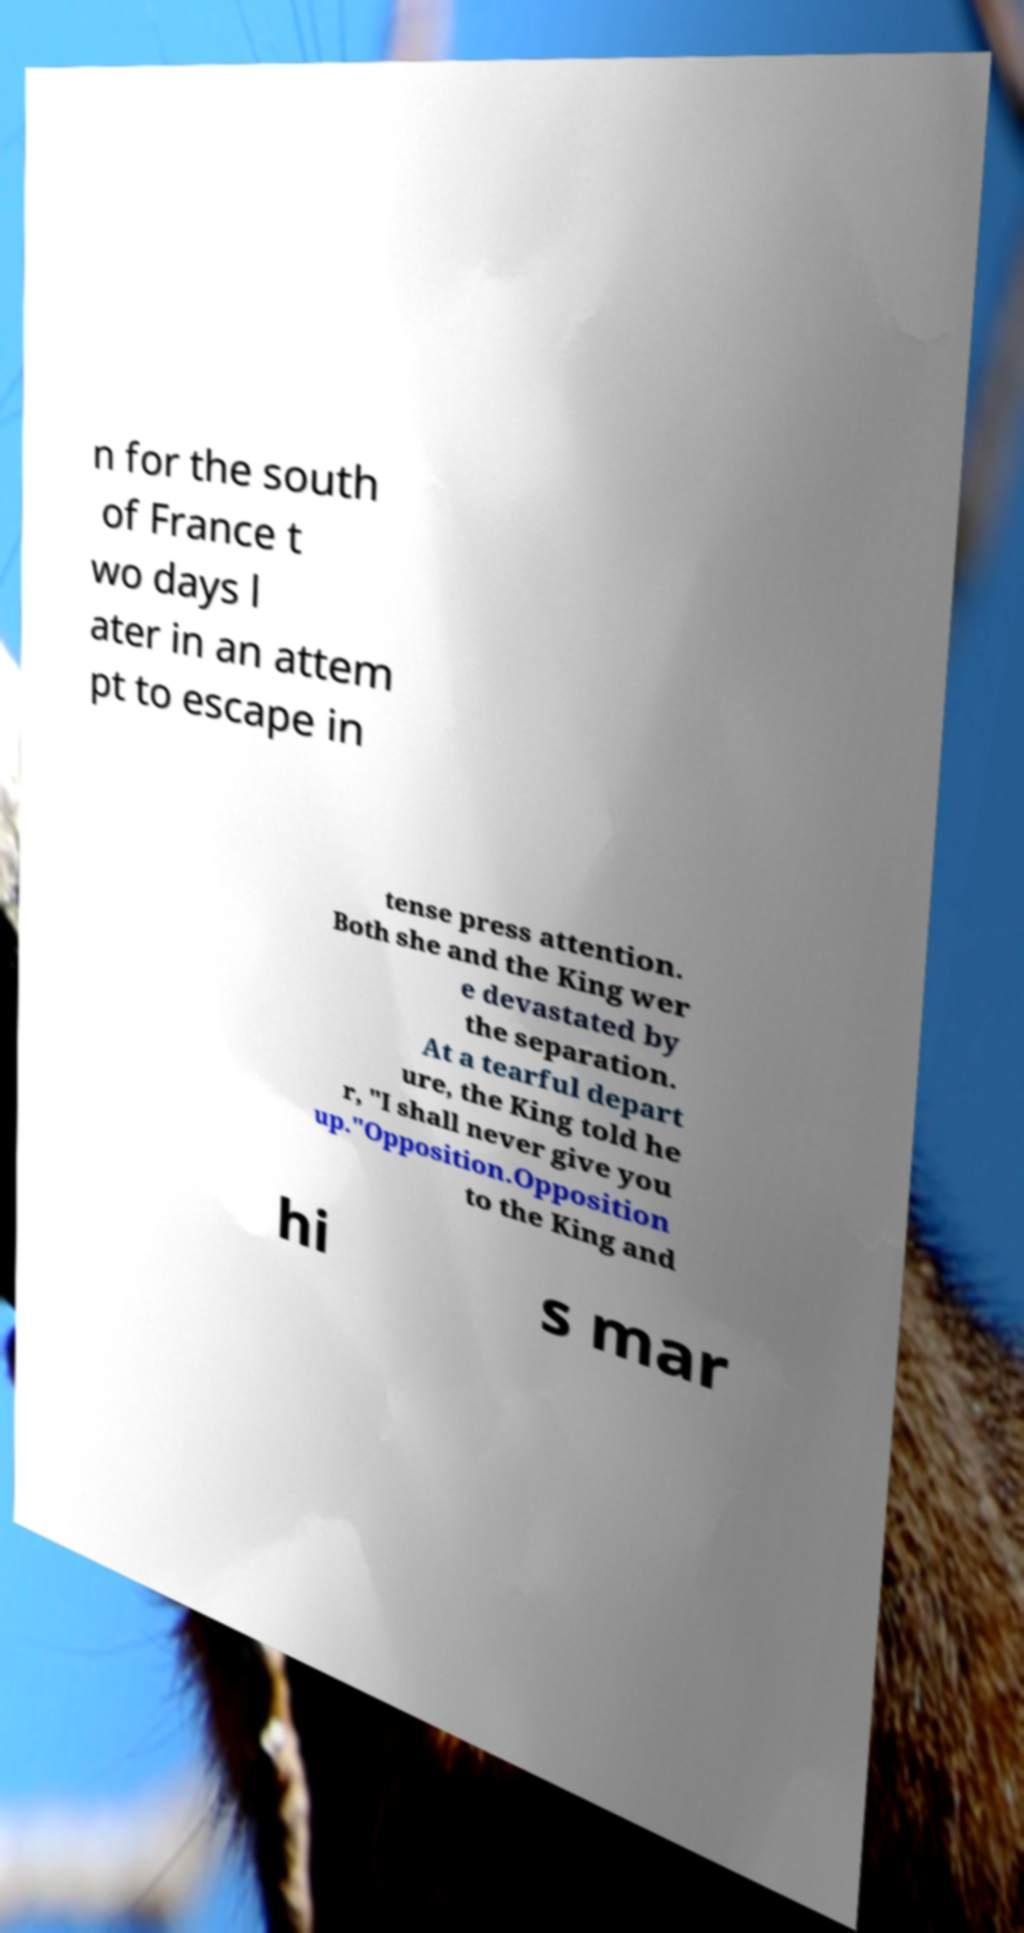Please identify and transcribe the text found in this image. n for the south of France t wo days l ater in an attem pt to escape in tense press attention. Both she and the King wer e devastated by the separation. At a tearful depart ure, the King told he r, "I shall never give you up."Opposition.Opposition to the King and hi s mar 